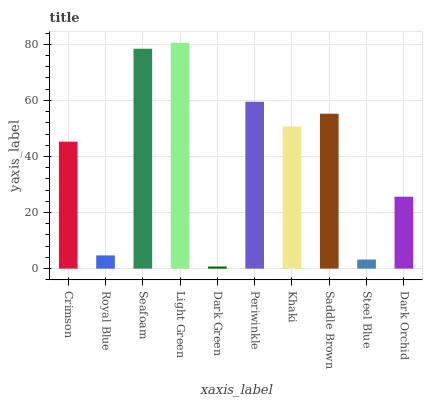Is Dark Green the minimum?
Answer yes or no. Yes. Is Light Green the maximum?
Answer yes or no. Yes. Is Royal Blue the minimum?
Answer yes or no. No. Is Royal Blue the maximum?
Answer yes or no. No. Is Crimson greater than Royal Blue?
Answer yes or no. Yes. Is Royal Blue less than Crimson?
Answer yes or no. Yes. Is Royal Blue greater than Crimson?
Answer yes or no. No. Is Crimson less than Royal Blue?
Answer yes or no. No. Is Khaki the high median?
Answer yes or no. Yes. Is Crimson the low median?
Answer yes or no. Yes. Is Royal Blue the high median?
Answer yes or no. No. Is Light Green the low median?
Answer yes or no. No. 